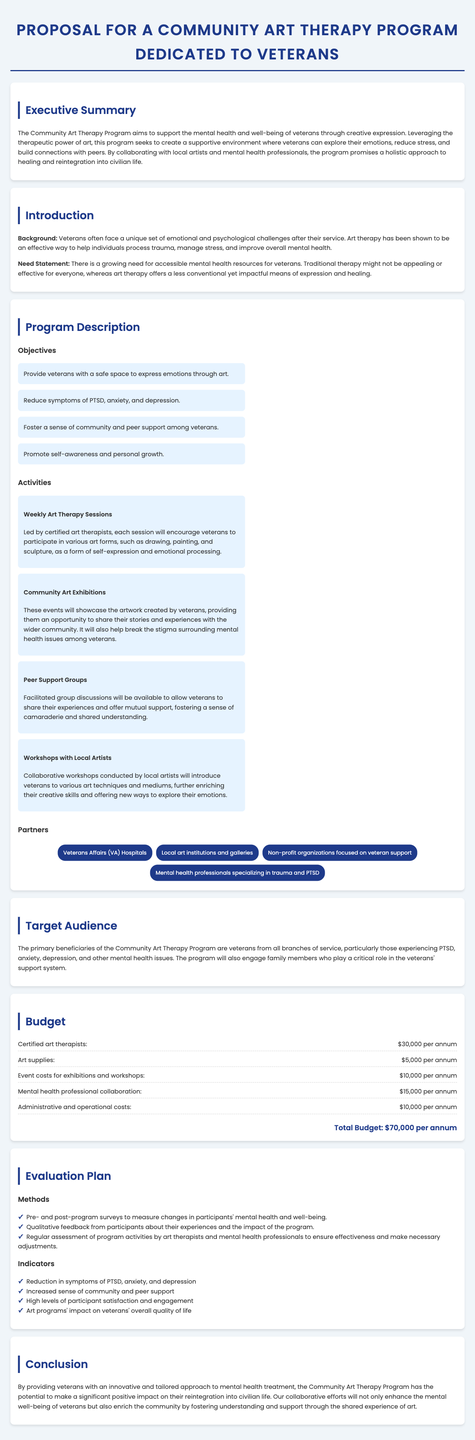what is the total budget for the program? The total budget is the cumulative expenses listed, which sum up to $70,000 per annum.
Answer: $70,000 per annum who are the primary beneficiaries of the program? The document specifies that the primary beneficiaries are veterans from all branches of service.
Answer: veterans what is one objective of the Community Art Therapy Program? The document lists multiple objectives including providing a safe space to express emotions through art.
Answer: Provide veterans with a safe space to express emotions through art what type of sessions will the program include? The proposal mentions weekly art therapy sessions led by certified art therapists.
Answer: Weekly art therapy sessions which organization is listed as a partner? The proposal identifies several partners including Veterans Affairs (VA) Hospitals.
Answer: Veterans Affairs (VA) Hospitals what is one method of evaluation mentioned in the plan? The evaluation plan includes pre- and post-program surveys to measure mental health changes.
Answer: Pre- and post-program surveys how many activities are described in the program section? The document outlines four specific activities related to the program.
Answer: four what is the focus of the workshops with local artists? The workshops are meant to introduce veterans to various art techniques and mediums.
Answer: Various art techniques and mediums 